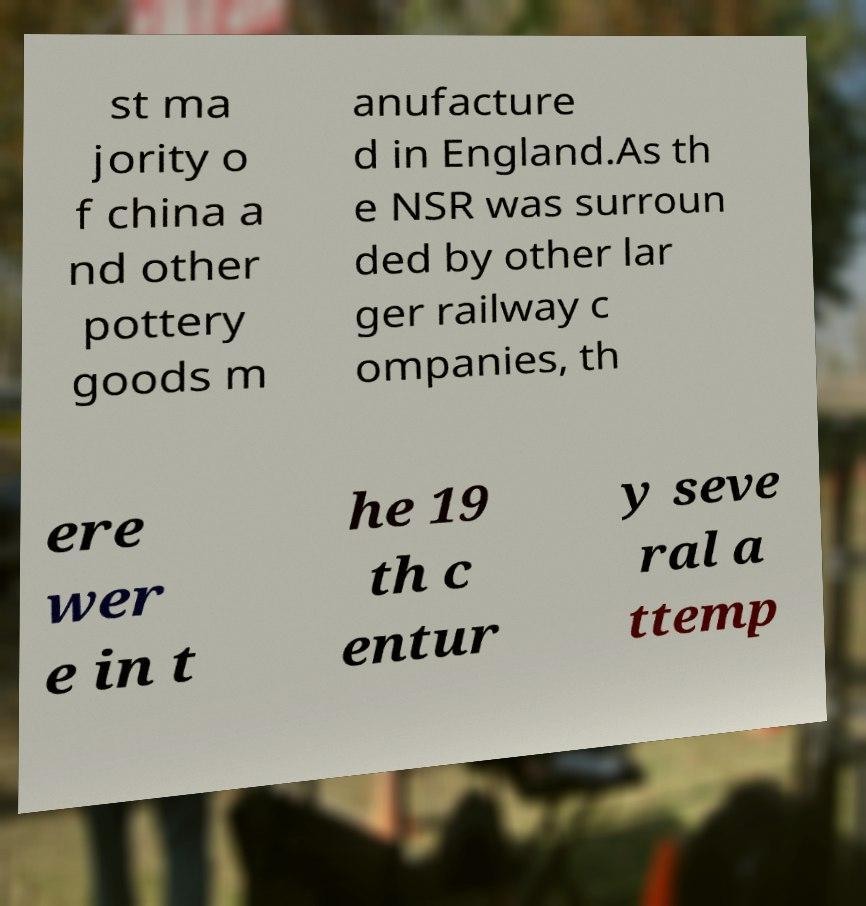Could you extract and type out the text from this image? st ma jority o f china a nd other pottery goods m anufacture d in England.As th e NSR was surroun ded by other lar ger railway c ompanies, th ere wer e in t he 19 th c entur y seve ral a ttemp 